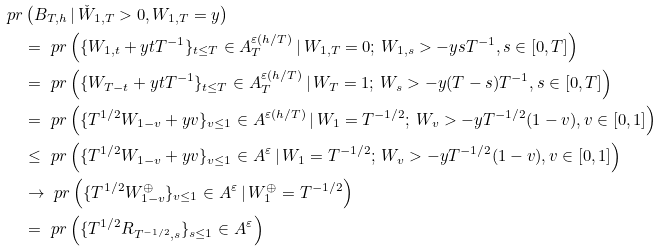Convert formula to latex. <formula><loc_0><loc_0><loc_500><loc_500>\ p r & \left ( B _ { T , h } \, | \, \check { W } _ { 1 , T } > 0 , W _ { 1 , T } = y \right ) \\ & = \ p r \left ( \{ W _ { 1 , t } + y t T ^ { - 1 } \} _ { t \leq T } \in A _ { T } ^ { \varepsilon ( h / T ) } \, | \, W _ { 1 , T } = 0 ; \, W _ { 1 , s } > - y s T ^ { - 1 } , s \in [ 0 , T ] \right ) \\ & = \ p r \left ( \{ W _ { T - t } + y t T ^ { - 1 } \} _ { t \leq T } \in A _ { T } ^ { \varepsilon ( h / T ) } \, | \, W _ { T } = 1 ; \, W _ { s } > - y ( T - s ) T ^ { - 1 } , s \in [ 0 , T ] \right ) \\ & = \ p r \left ( \{ T ^ { 1 / 2 } W _ { 1 - v } + y v \} _ { v \leq 1 } \in A ^ { \varepsilon ( h / T ) } \, | \, W _ { 1 } = T ^ { - 1 / 2 } ; \, W _ { v } > - y T ^ { - 1 / 2 } ( 1 - v ) , v \in [ 0 , 1 ] \right ) \\ & \leq \ p r \left ( \{ T ^ { 1 / 2 } W _ { 1 - v } + y v \} _ { v \leq 1 } \in A ^ { \varepsilon } \, | \, W _ { 1 } = T ^ { - 1 / 2 } ; \, W _ { v } > - y T ^ { - 1 / 2 } ( 1 - v ) , v \in [ 0 , 1 ] \right ) \\ & \to \ p r \left ( \{ T ^ { 1 / 2 } W ^ { \oplus } _ { 1 - v } \} _ { v \leq 1 } \in A ^ { \varepsilon } \, | \, W ^ { \oplus } _ { 1 } = T ^ { - 1 / 2 } \right ) \\ & = \ p r \left ( \{ T ^ { 1 / 2 } R _ { T ^ { - 1 / 2 } , s } \} _ { s \leq 1 } \in A ^ { \varepsilon } \right )</formula> 